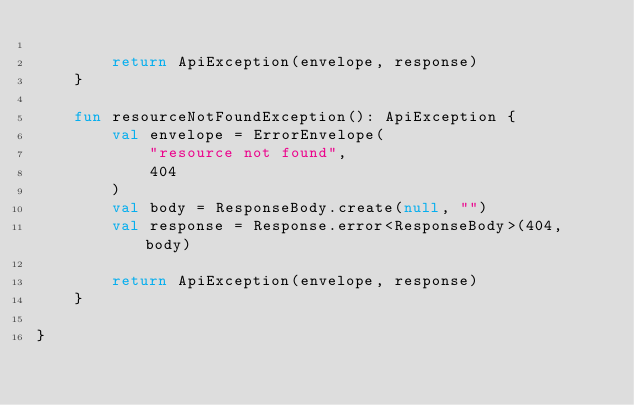Convert code to text. <code><loc_0><loc_0><loc_500><loc_500><_Kotlin_>
        return ApiException(envelope, response)
    }

    fun resourceNotFoundException(): ApiException {
        val envelope = ErrorEnvelope(
            "resource not found",
            404
        )
        val body = ResponseBody.create(null, "")
        val response = Response.error<ResponseBody>(404, body)

        return ApiException(envelope, response)
    }

}</code> 